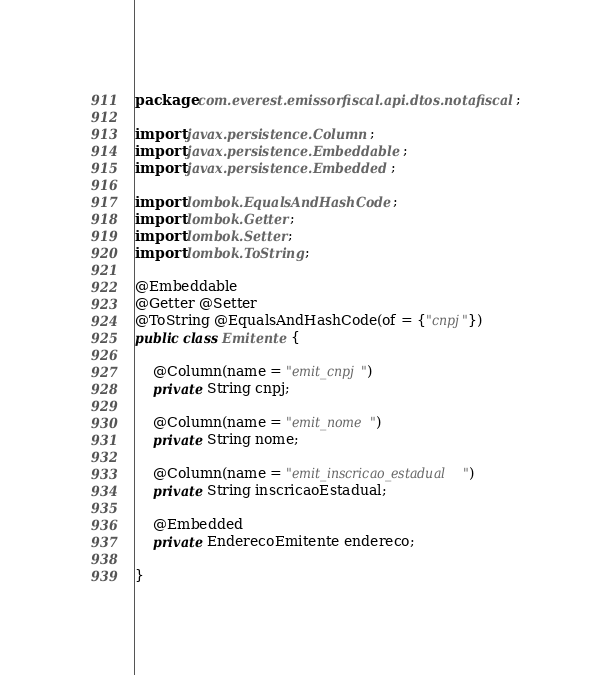Convert code to text. <code><loc_0><loc_0><loc_500><loc_500><_Java_>package com.everest.emissorfiscal.api.dtos.notafiscal;

import javax.persistence.Column;
import javax.persistence.Embeddable;
import javax.persistence.Embedded;

import lombok.EqualsAndHashCode;
import lombok.Getter;
import lombok.Setter;
import lombok.ToString;

@Embeddable
@Getter @Setter 
@ToString @EqualsAndHashCode(of = {"cnpj"})
public class Emitente {
	
	@Column(name = "emit_cnpj")
	private String cnpj;

	@Column(name = "emit_nome")
	private String nome;

	@Column(name = "emit_inscricao_estadual")
	private String inscricaoEstadual;

	@Embedded
	private EnderecoEmitente endereco;	
	
}
</code> 